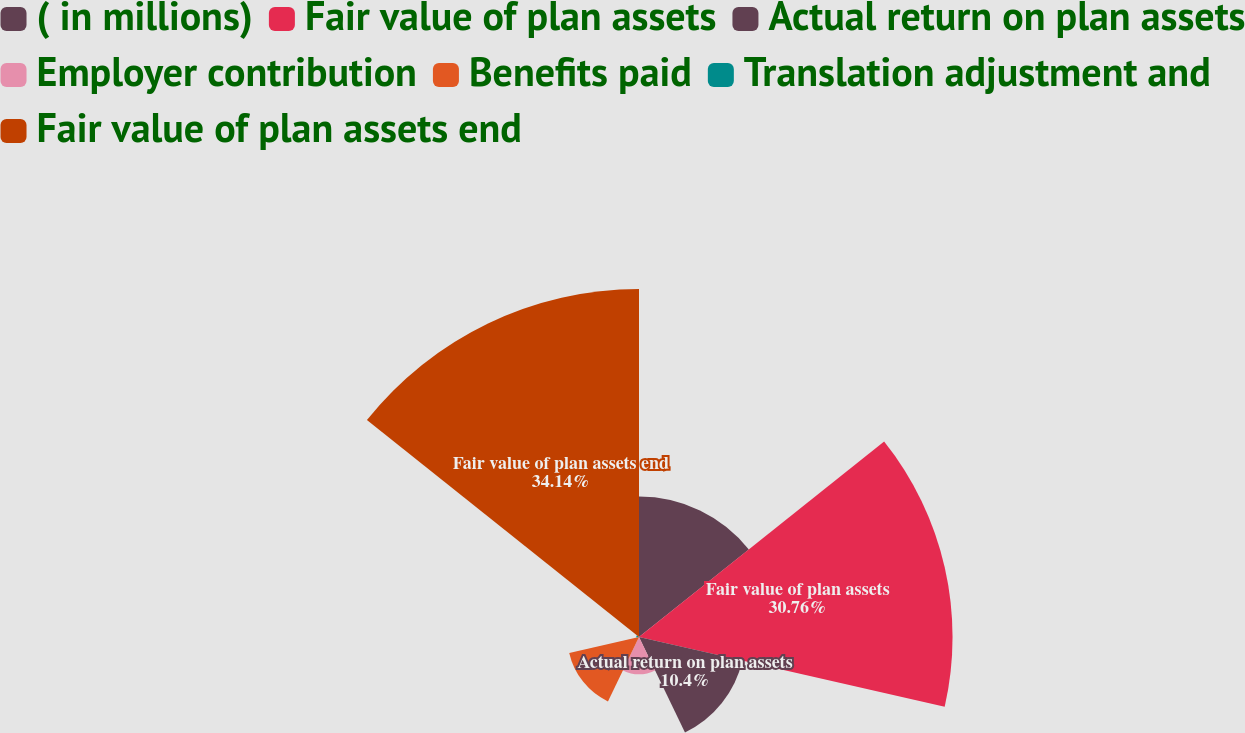Convert chart. <chart><loc_0><loc_0><loc_500><loc_500><pie_chart><fcel>( in millions)<fcel>Fair value of plan assets<fcel>Actual return on plan assets<fcel>Employer contribution<fcel>Benefits paid<fcel>Translation adjustment and<fcel>Fair value of plan assets end<nl><fcel>13.78%<fcel>30.76%<fcel>10.4%<fcel>3.64%<fcel>7.02%<fcel>0.26%<fcel>34.14%<nl></chart> 